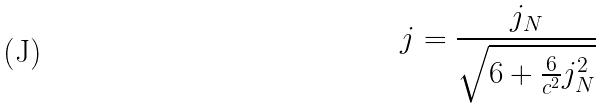Convert formula to latex. <formula><loc_0><loc_0><loc_500><loc_500>j = \frac { j _ { N } } { \sqrt { 6 + \frac { 6 } { c ^ { 2 } } j _ { N } ^ { 2 } } }</formula> 